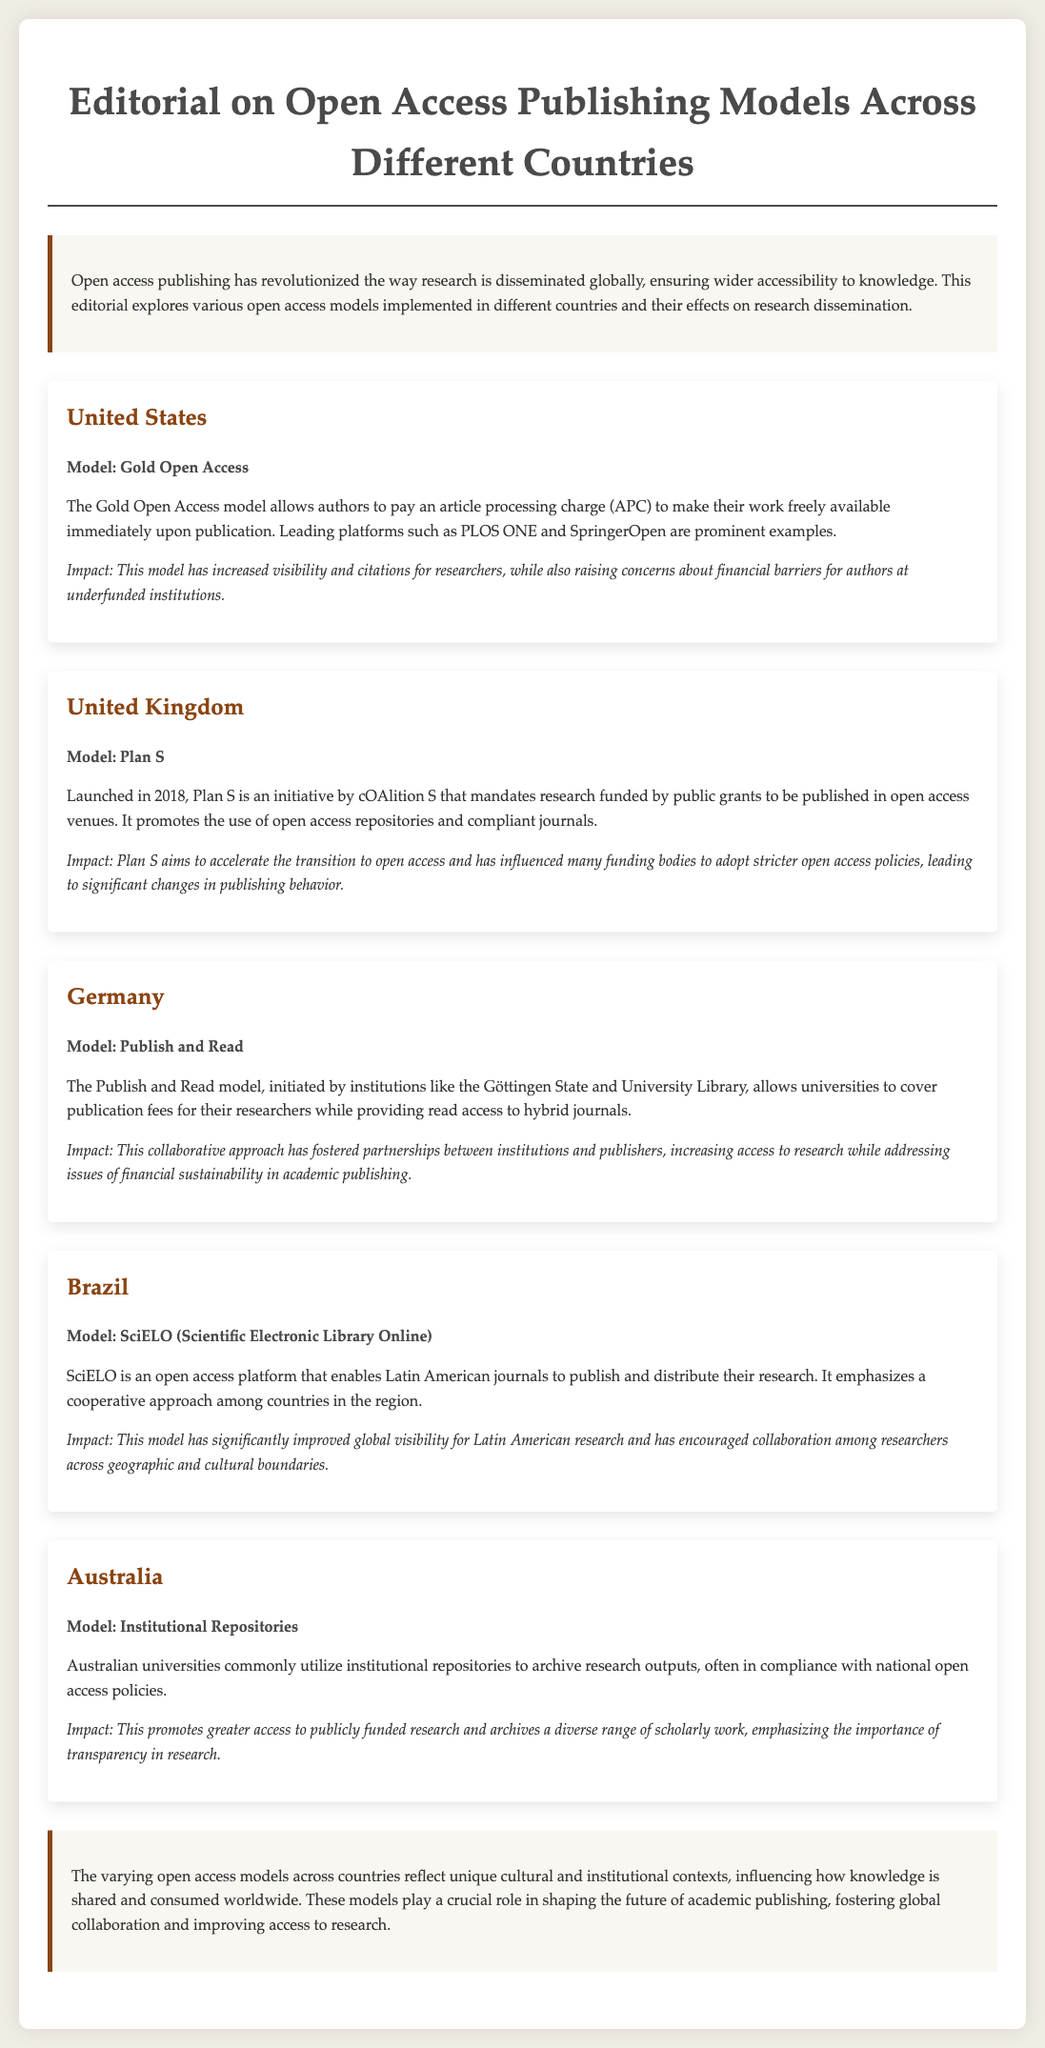What open access model is used in the United States? The document specifies that the Gold Open Access model allows authors to pay an article processing charge to make their work freely available.
Answer: Gold Open Access What initiative was launched in the United Kingdom in 2018? The document states that Plan S is an initiative by cOAlition S that mandates research funded by public grants to be published in open access venues.
Answer: Plan S Which model originated in Germany and involves covering publication fees? The document describes the Publish and Read model, initiated by institutions like the Göttingen State and University Library, that allows universities to cover publication fees.
Answer: Publish and Read What is the primary impact of Brazil's SciELO model? The document highlights that SciELO has significantly improved global visibility for Latin American research and encouraged collaboration among researchers.
Answer: Improved global visibility What approach to archiving research is commonly utilized by Australian universities? The document mentions that Australian universities utilize institutional repositories to archive research outputs.
Answer: Institutional Repositories How do the various open access models impact research dissemination? The document concludes that varying open access models reflect unique cultural and institutional contexts that influence how knowledge is shared.
Answer: Influence knowledge sharing How does Plan S aim to affect publishing behavior? The document notes that Plan S aims to accelerate the transition to open access, influencing funding bodies to adopt stricter open access policies.
Answer: Accelerate transition to open access What is emphasized by the SciELO model regarding cooperation? The document specifies that SciELO emphasizes a cooperative approach among countries in the region.
Answer: Cooperative approach What role does transparency play in Australian institutional repositories according to the document? The document indicates that institutional repositories promote greater access to publicly funded research and emphasize the importance of transparency.
Answer: Importance of transparency 